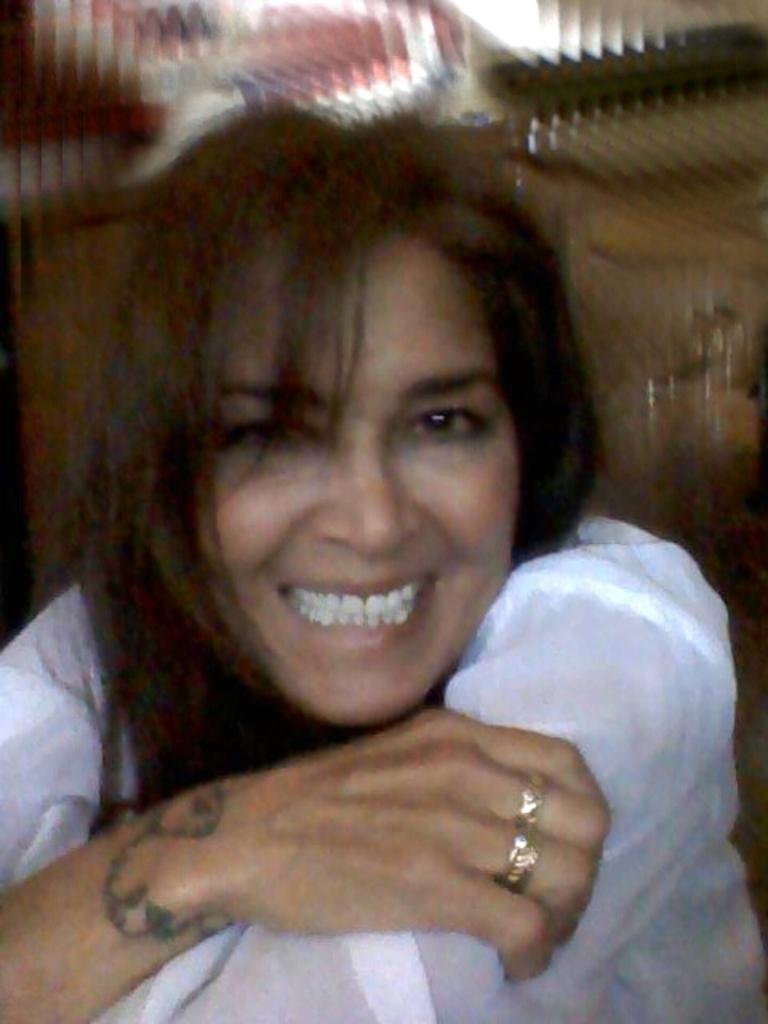Who is present in the image? There is a woman in the image. What is the woman wearing? The woman is wearing a white dress. What type of pizzas are being served at the event in the image? There is no event or pizzas present in the image; it only features a woman wearing a white dress. 